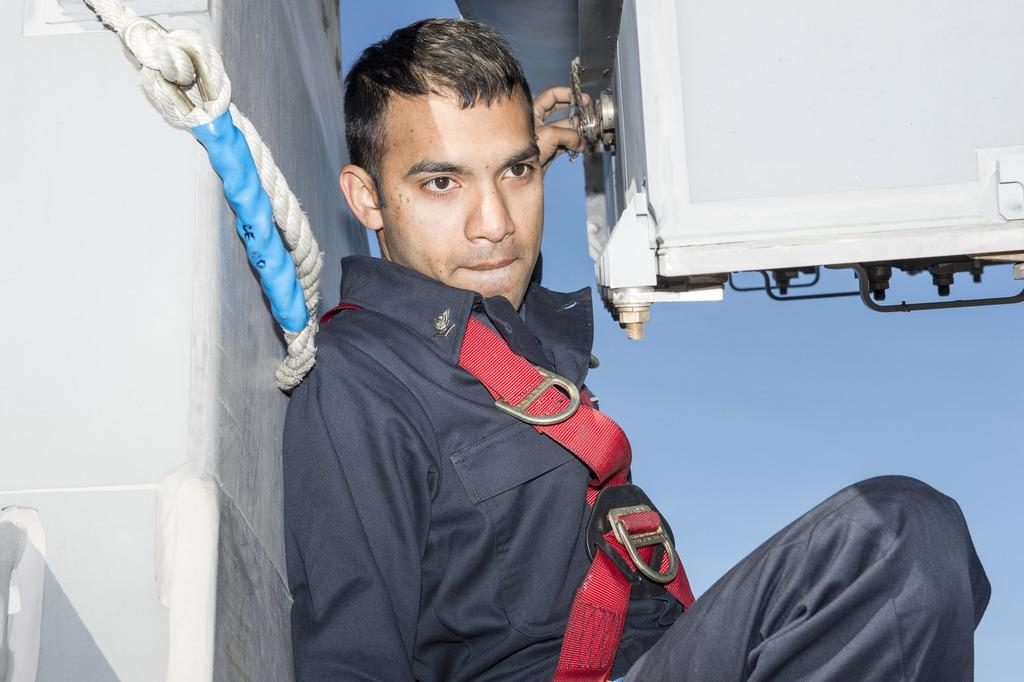What is the main subject of the image? There is a person in the image. What is the person doing in the image? The person is leaning on a wall and holding a rope. What is in front of the person? There is an object in front of the person. How many eyes can be seen on the leaf in the image? There is no leaf present in the image, and therefore no eyes can be seen on a leaf. 